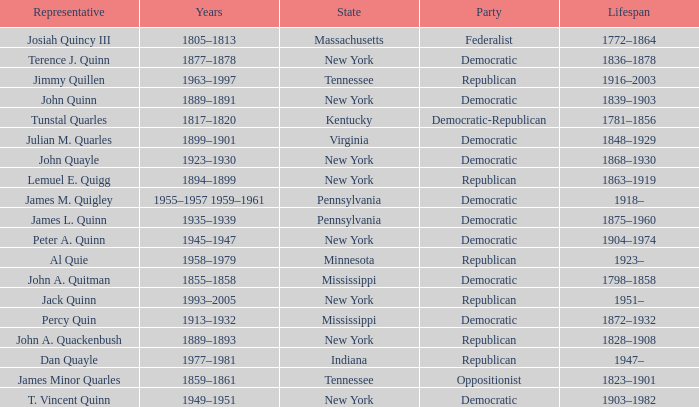Which party has Peter A. Quinn as a representative? Democratic. 